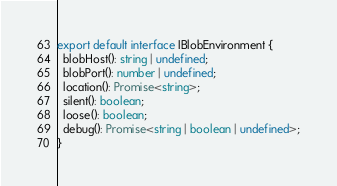<code> <loc_0><loc_0><loc_500><loc_500><_TypeScript_>export default interface IBlobEnvironment {
  blobHost(): string | undefined;
  blobPort(): number | undefined;
  location(): Promise<string>;
  silent(): boolean;
  loose(): boolean;
  debug(): Promise<string | boolean | undefined>;
}
</code> 